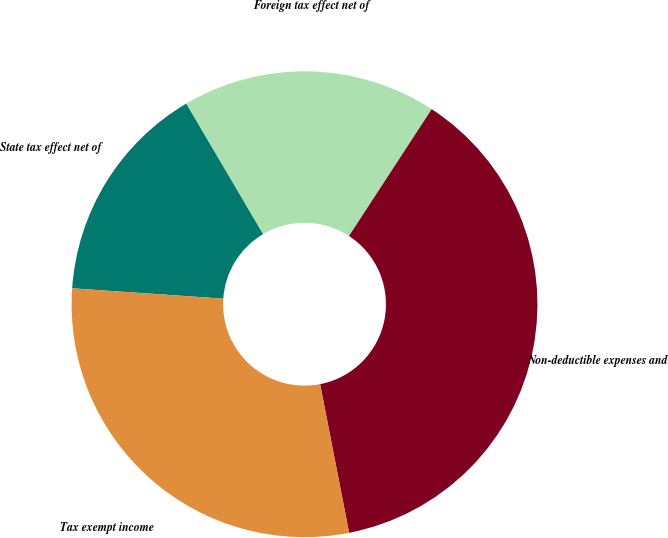Convert chart. <chart><loc_0><loc_0><loc_500><loc_500><pie_chart><fcel>State tax effect net of<fcel>Foreign tax effect net of<fcel>Non-deductible expenses and<fcel>Tax exempt income<nl><fcel>15.44%<fcel>17.67%<fcel>37.74%<fcel>29.16%<nl></chart> 